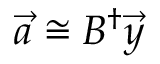<formula> <loc_0><loc_0><loc_500><loc_500>\vec { a } \cong B ^ { \dagger } \vec { y }</formula> 